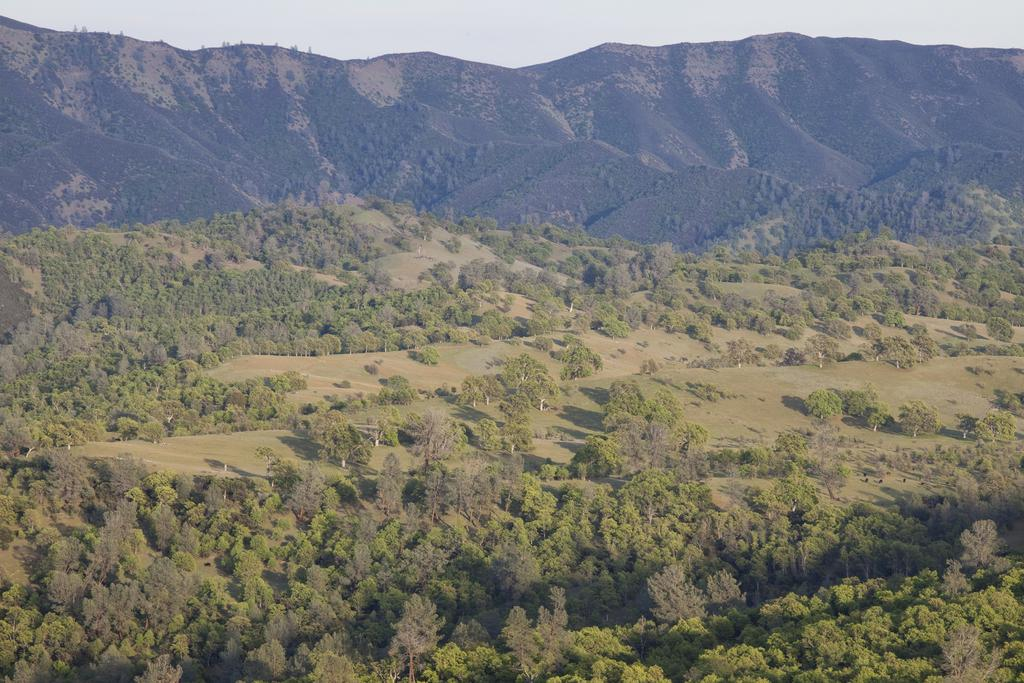What is the main subject of the image? The main subject of the image is a mountain. How many mountains can be seen in the image? There are multiple mountains in the image. What type of vegetation is present in the image? There are trees in the image. What is visible at the top of the image? The sky is visible at the top of the image. What type of ground cover is present at the bottom of the image? Grass is present at the bottom of the image. What type of punishment is being handed out to the mountain in the image? There is no punishment being handed out to the mountain in the image; it is a natural landscape. 